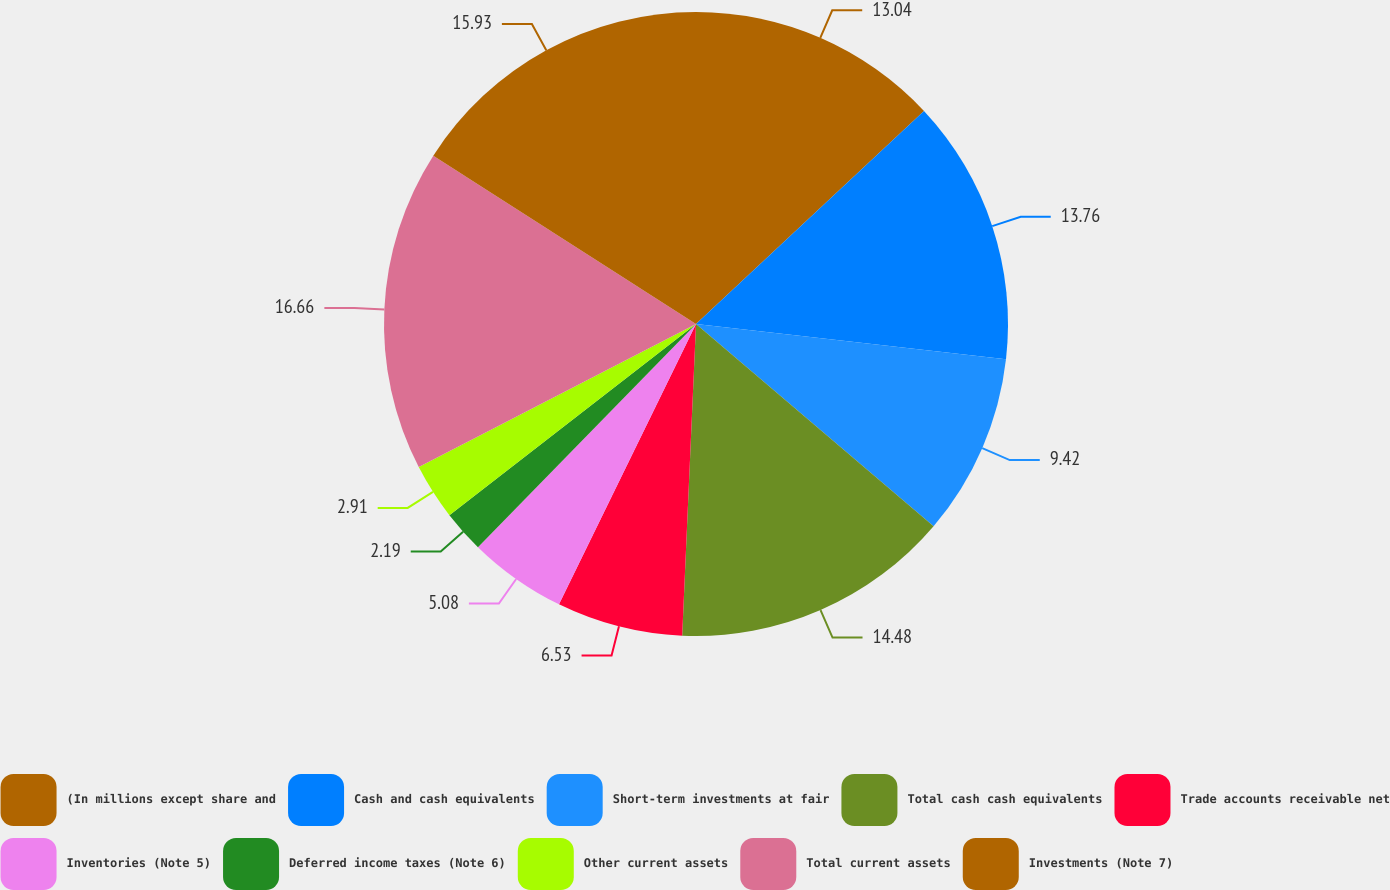<chart> <loc_0><loc_0><loc_500><loc_500><pie_chart><fcel>(In millions except share and<fcel>Cash and cash equivalents<fcel>Short-term investments at fair<fcel>Total cash cash equivalents<fcel>Trade accounts receivable net<fcel>Inventories (Note 5)<fcel>Deferred income taxes (Note 6)<fcel>Other current assets<fcel>Total current assets<fcel>Investments (Note 7)<nl><fcel>13.04%<fcel>13.76%<fcel>9.42%<fcel>14.48%<fcel>6.53%<fcel>5.08%<fcel>2.19%<fcel>2.91%<fcel>16.65%<fcel>15.93%<nl></chart> 